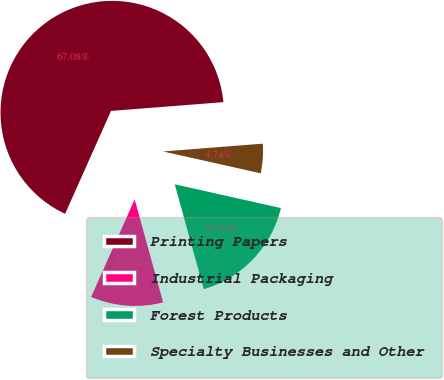Convert chart to OTSL. <chart><loc_0><loc_0><loc_500><loc_500><pie_chart><fcel>Printing Papers<fcel>Industrial Packaging<fcel>Forest Products<fcel>Specialty Businesses and Other<nl><fcel>67.08%<fcel>10.97%<fcel>17.21%<fcel>4.74%<nl></chart> 